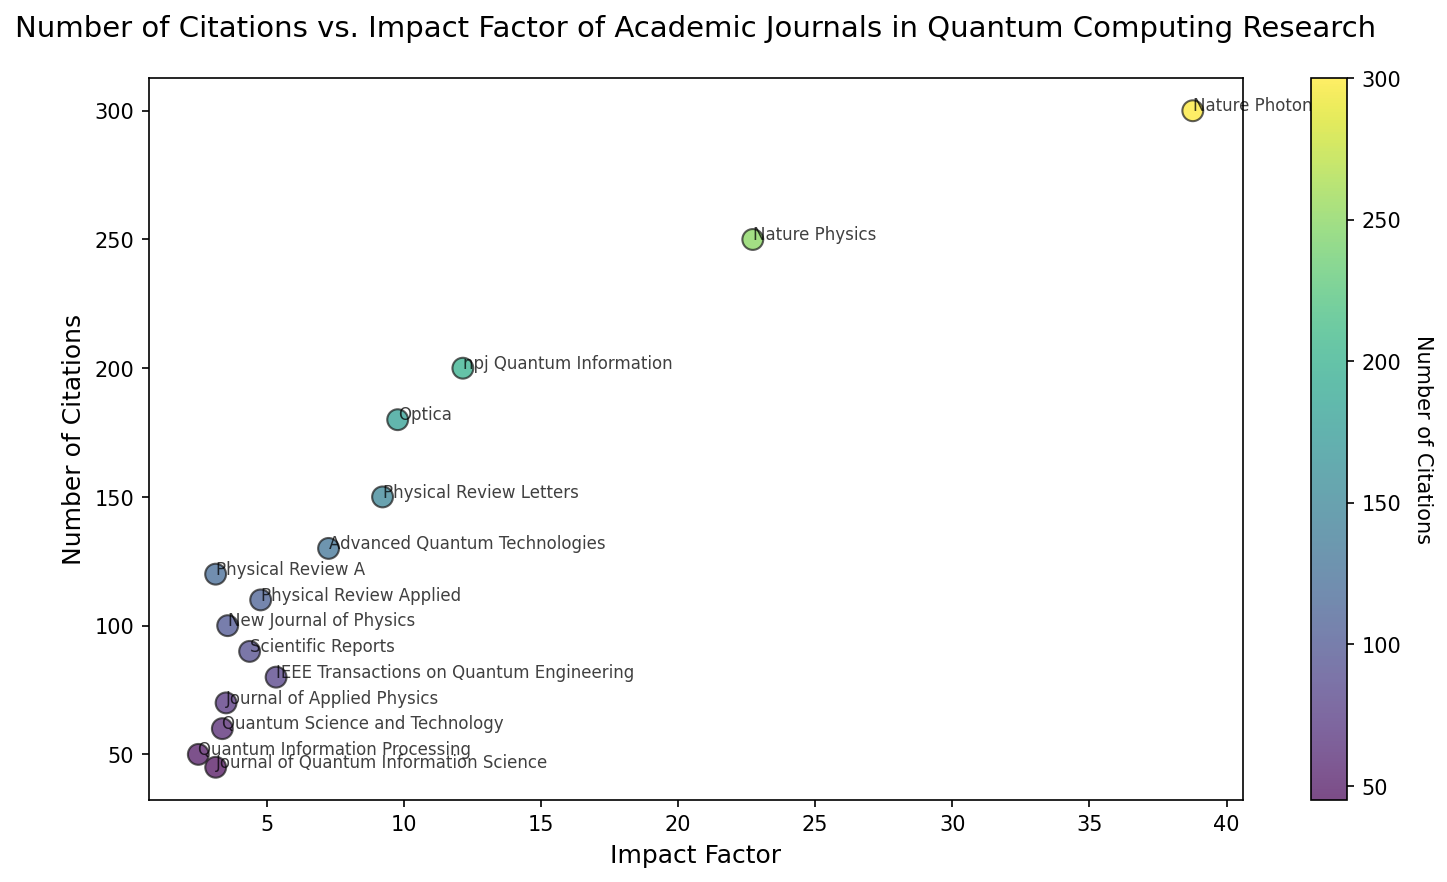What's the journal with the lowest impact factor, and how many citations does it have? The scatter plot has various journals labeled. From these, the journal with the lowest impact factor is 'Quantum Information Processing', which has an impact factor of 2.509. From the plot, it can be seen that this journal has 50 citations.
Answer: Quantum Information Processing, 50 Which journal has the highest number of citations, and what is its impact factor? By inspecting the plot, the journal with the highest number of citations is 'Nature Photonics', which has 300 citations. Its impact factor is 38.771. This can be found where the data point is located the highest along the y-axis.
Answer: Nature Photonics, 38.771 What's the difference in the number of citations between 'Physical Review Letters' and 'Nature Physics'? Observing the scatter plot, 'Physical Review Letters' has 150 citations, and 'Nature Physics' has 250 citations. The difference is calculated as 250 - 150 = 100.
Answer: 100 Are there any journals with both an impact factor greater than 10 and more than 150 citations? If so, name them. From the plot, journals with an impact factor greater than 10 and more than 150 citations can be identified. 'Nature Photonics' (Impact Factor 38.771, 300 citations) and 'npj Quantum Information' (Impact Factor 12.155, 200 citations) meet this criterion. Both can be found in the upper-right quadrant of the scatter plot.
Answer: Nature Photonics, npj Quantum Information Which journal has a similar number of citations as 'Optica' but a different impact factor? 'Optica' has 180 citations. By inspecting the plot for a data point close to this value along the y-axis, 'npj Quantum Information' can be identified, which has 200 citations (another close match). The impact factor for 'Optica' is 9.778, while for 'npj Quantum Information' it is 12.155, showing a different impact factor.
Answer: npj Quantum Information What's the average impact factor of journals with less than 100 citations? Identifying journals with citations less than 100: Quantum Information Processing (2.509), IEEE Transactions on Quantum Engineering (5.345), Journal of Quantum Information Science (3.142), Quantum Science and Technology (3.385), Journal of Applied Physics (3.521), New Journal of Physics (3.579). Summing their impact factors and dividing by 6: (2.509 + 5.345 + 3.142 + 3.385 + 3.521 + 3.579) / 6 ≈ 3.580.
Answer: 3.580 Which journal with an impact factor around 4 has the maximum number of citations? From the scatter plot, journals with an impact factor around 4 include 'Scientific Reports' (4.379) and 'Physical Review Applied' (4.782). Among these, 'Physical Review Applied' has more citations (110 compared to 90).
Answer: Physical Review Applied How many journals have impact factors between 5 and 10? Inspecting the scatter plot reveals journals with impact factors between 5 and 10: Physical Review Letters, IEEE Transactions on Quantum Engineering, Scientific Reports, Optica, and Advanced Quantum Technologies. Counting these journals gives a total of 5.
Answer: 5 